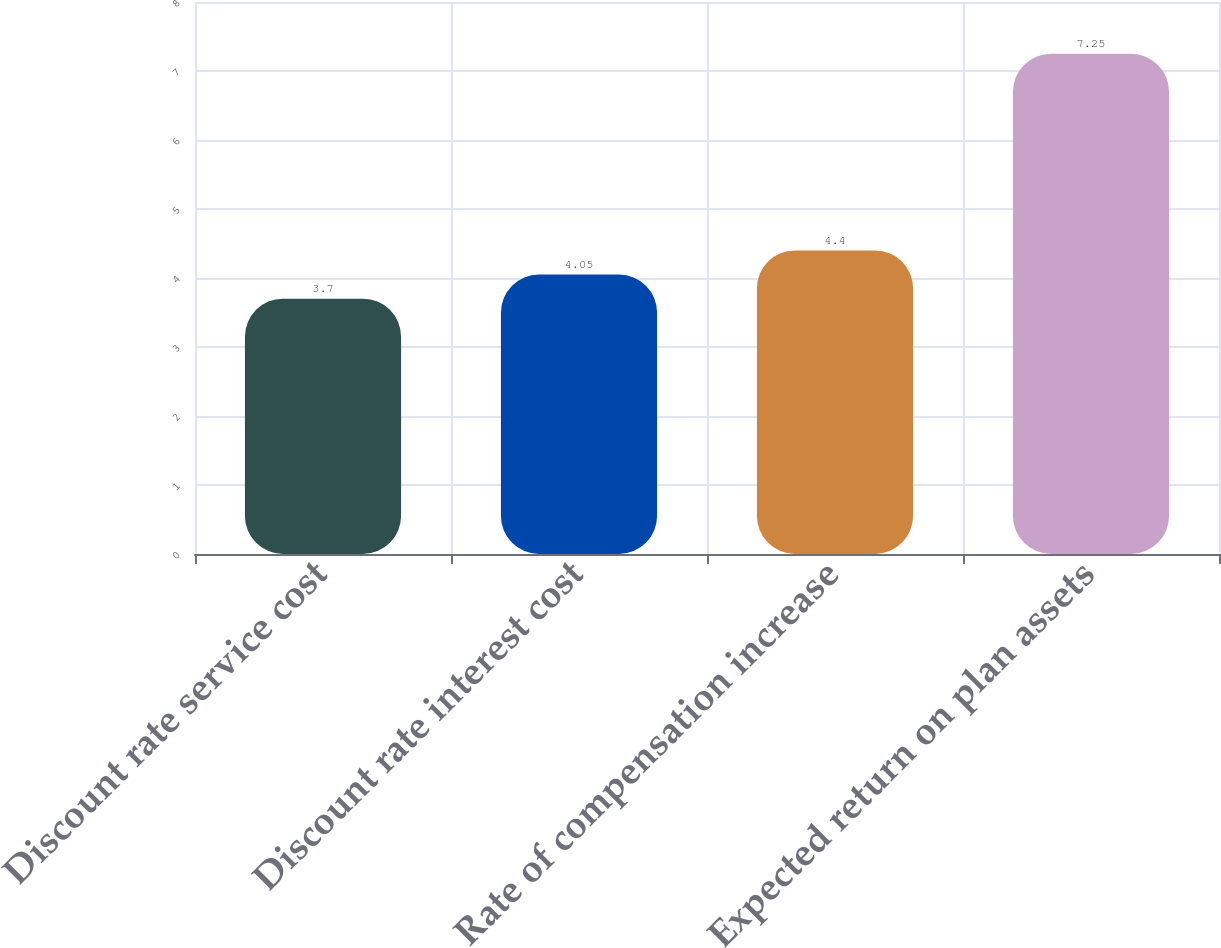Convert chart. <chart><loc_0><loc_0><loc_500><loc_500><bar_chart><fcel>Discount rate service cost<fcel>Discount rate interest cost<fcel>Rate of compensation increase<fcel>Expected return on plan assets<nl><fcel>3.7<fcel>4.05<fcel>4.4<fcel>7.25<nl></chart> 